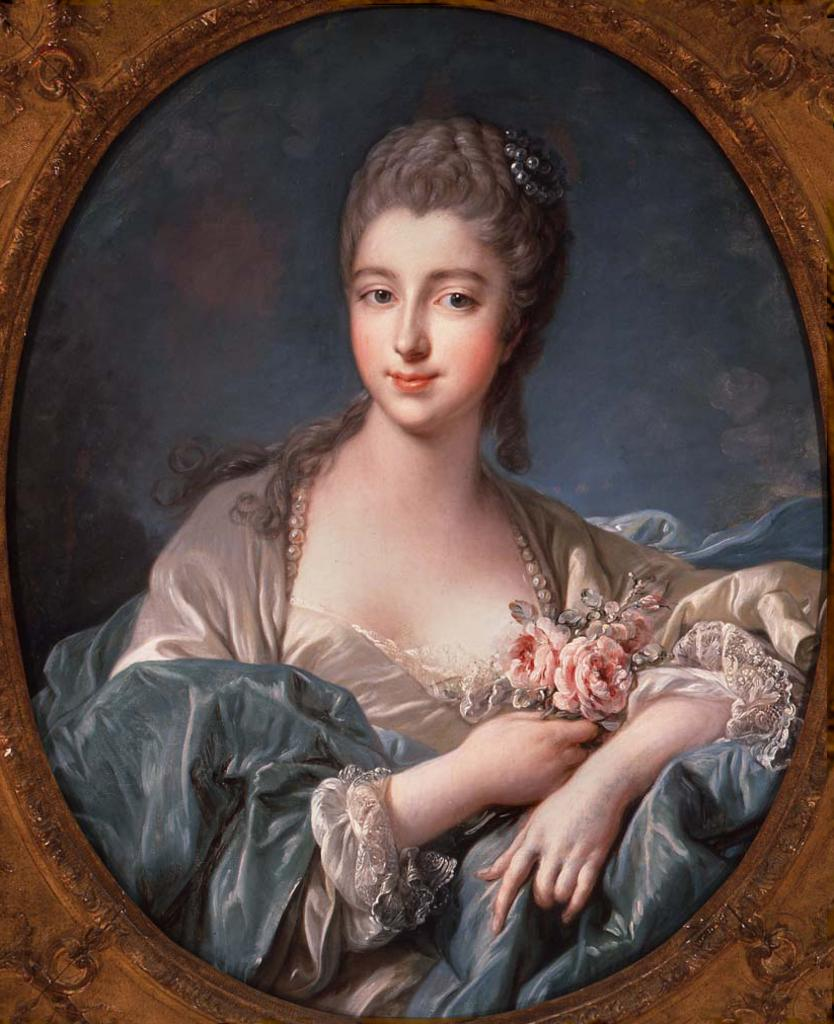What is the main subject of the painting in the image? The main subject of the painting in the image is a woman. Where is the painting located within the image? The painting is in the middle of the image. What type of finger can be seen holding the veil in the painting? There is no finger or veil present in the painting; it only depicts a woman. What type of harbor can be seen in the background of the painting? There is no harbor present in the painting; it only depicts a woman. 